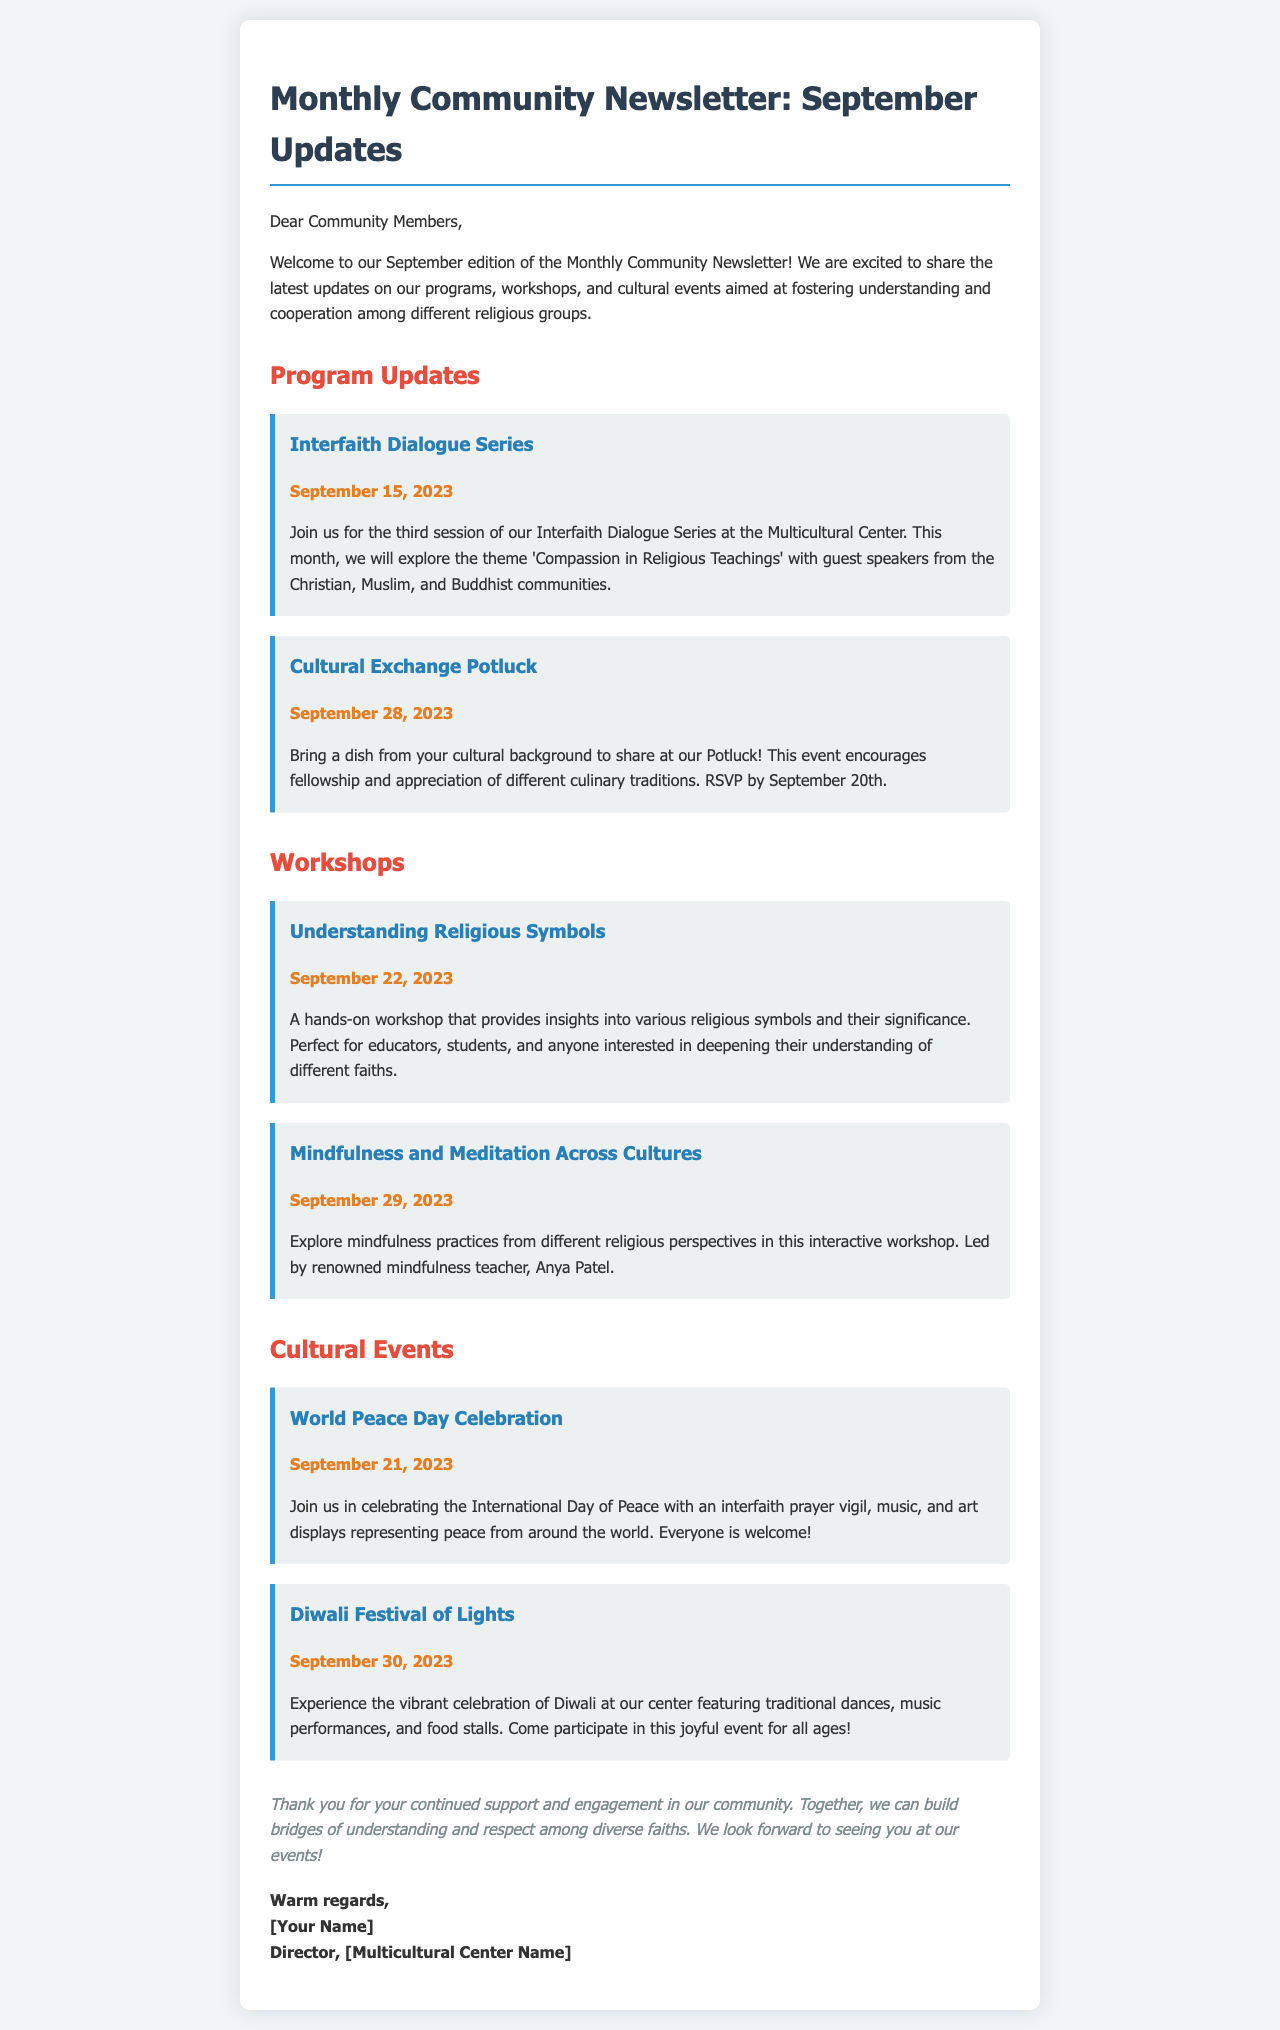What is the title of this newsletter? The title of the newsletter is the main heading that introduces the content, which is "Monthly Community Newsletter: September Updates."
Answer: Monthly Community Newsletter: September Updates When is the Interfaith Dialogue Series taking place? The date in the document indicates when the specific event will occur, which is September 15, 2023.
Answer: September 15, 2023 What is the theme of this month's Interfaith Dialogue Series? The theme, as mentioned in the document, is a specific topic discussed in the event, which is 'Compassion in Religious Teachings.'
Answer: Compassion in Religious Teachings What type of event is scheduled for September 28, 2023? The document notes the type of event that will happen on that date, specifically a Potluck.
Answer: Cultural Exchange Potluck Who is leading the workshop on mindfulness? The document mentions the name of the individual leading the workshop, which is Anya Patel.
Answer: Anya Patel How many events are listed under Cultural Events? To find the number of events, count the entries in the Cultural Events section, which lists two events.
Answer: 2 What is required to attend the Cultural Exchange Potluck event? The document states an action that participants need to take to attend, which is to RSVP by September 20th.
Answer: RSVP by September 20th What is the main goal of the community center as stated in the newsletter? The goal mentioned in the closing paragraph expresses the intention of the community center, which is to build bridges of understanding and respect among diverse faiths.
Answer: Building bridges of understanding and respect among diverse faiths 